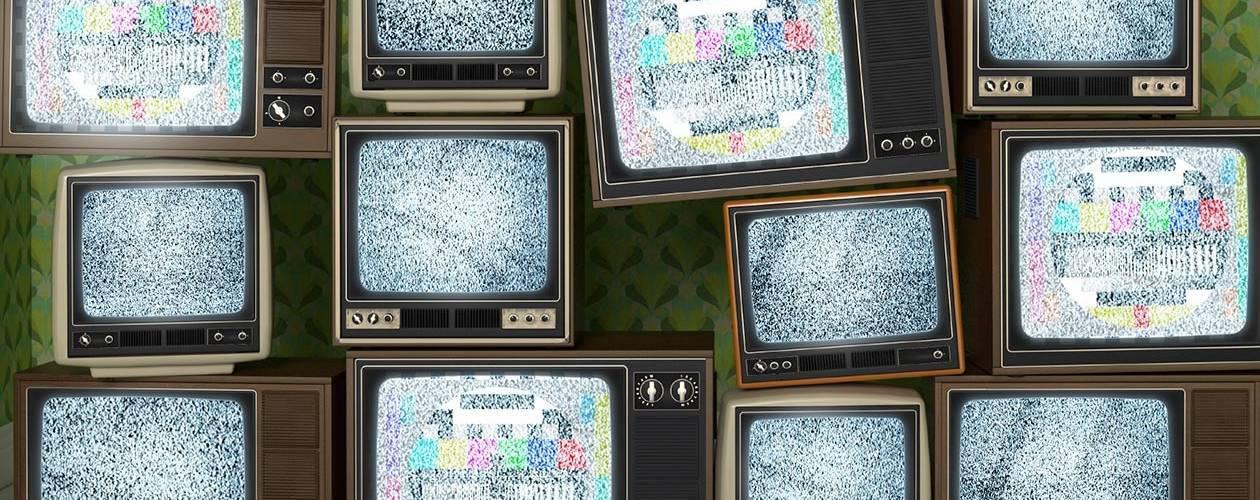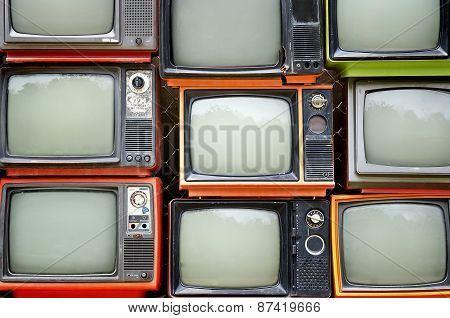The first image is the image on the left, the second image is the image on the right. For the images displayed, is the sentence "Each image shows vertical stacks containing at least eight TV sets, and no image includes any part of a human." factually correct? Answer yes or no. Yes. The first image is the image on the left, the second image is the image on the right. For the images displayed, is the sentence "There are less than five television sets  in at least one of the images." factually correct? Answer yes or no. No. 